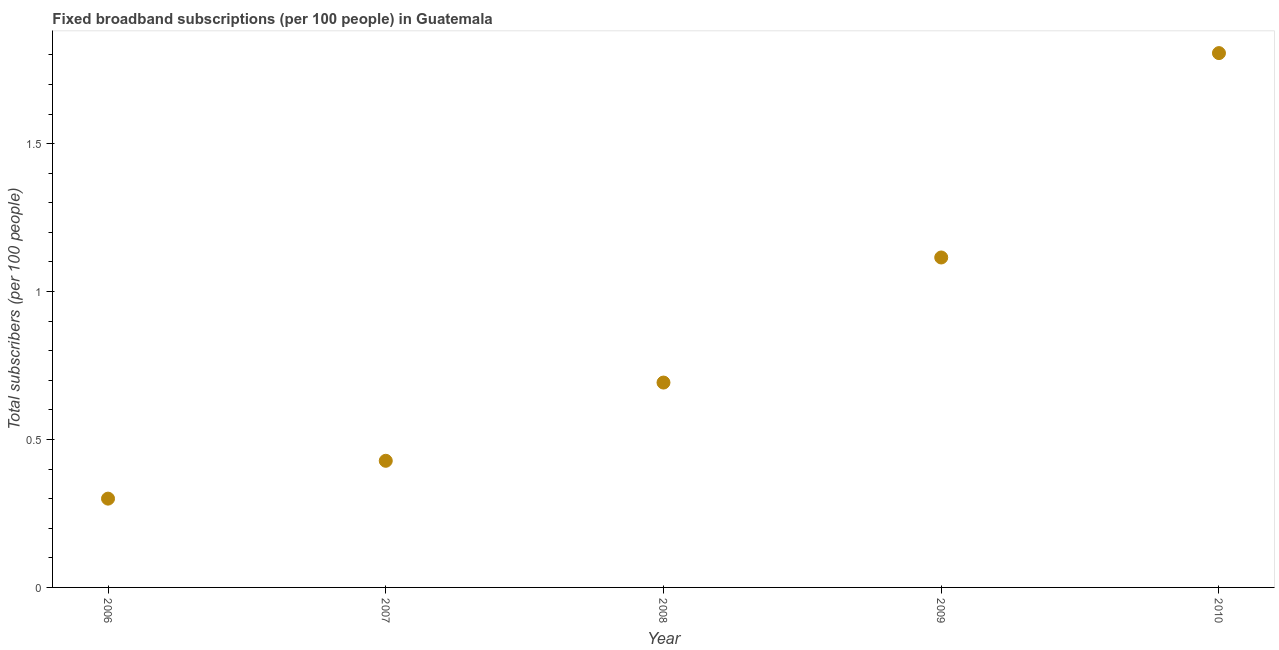What is the total number of fixed broadband subscriptions in 2010?
Offer a very short reply. 1.81. Across all years, what is the maximum total number of fixed broadband subscriptions?
Your answer should be compact. 1.81. Across all years, what is the minimum total number of fixed broadband subscriptions?
Provide a short and direct response. 0.3. In which year was the total number of fixed broadband subscriptions maximum?
Keep it short and to the point. 2010. In which year was the total number of fixed broadband subscriptions minimum?
Ensure brevity in your answer.  2006. What is the sum of the total number of fixed broadband subscriptions?
Your answer should be very brief. 4.34. What is the difference between the total number of fixed broadband subscriptions in 2006 and 2009?
Your answer should be compact. -0.82. What is the average total number of fixed broadband subscriptions per year?
Offer a terse response. 0.87. What is the median total number of fixed broadband subscriptions?
Ensure brevity in your answer.  0.69. In how many years, is the total number of fixed broadband subscriptions greater than 0.4 ?
Provide a short and direct response. 4. What is the ratio of the total number of fixed broadband subscriptions in 2008 to that in 2009?
Your response must be concise. 0.62. Is the difference between the total number of fixed broadband subscriptions in 2008 and 2009 greater than the difference between any two years?
Provide a succinct answer. No. What is the difference between the highest and the second highest total number of fixed broadband subscriptions?
Ensure brevity in your answer.  0.69. Is the sum of the total number of fixed broadband subscriptions in 2006 and 2007 greater than the maximum total number of fixed broadband subscriptions across all years?
Your answer should be compact. No. What is the difference between the highest and the lowest total number of fixed broadband subscriptions?
Offer a terse response. 1.51. Does the graph contain any zero values?
Offer a very short reply. No. What is the title of the graph?
Keep it short and to the point. Fixed broadband subscriptions (per 100 people) in Guatemala. What is the label or title of the X-axis?
Your answer should be very brief. Year. What is the label or title of the Y-axis?
Ensure brevity in your answer.  Total subscribers (per 100 people). What is the Total subscribers (per 100 people) in 2006?
Ensure brevity in your answer.  0.3. What is the Total subscribers (per 100 people) in 2007?
Provide a succinct answer. 0.43. What is the Total subscribers (per 100 people) in 2008?
Offer a terse response. 0.69. What is the Total subscribers (per 100 people) in 2009?
Provide a succinct answer. 1.12. What is the Total subscribers (per 100 people) in 2010?
Your answer should be compact. 1.81. What is the difference between the Total subscribers (per 100 people) in 2006 and 2007?
Provide a short and direct response. -0.13. What is the difference between the Total subscribers (per 100 people) in 2006 and 2008?
Your answer should be very brief. -0.39. What is the difference between the Total subscribers (per 100 people) in 2006 and 2009?
Your answer should be very brief. -0.82. What is the difference between the Total subscribers (per 100 people) in 2006 and 2010?
Provide a succinct answer. -1.51. What is the difference between the Total subscribers (per 100 people) in 2007 and 2008?
Give a very brief answer. -0.26. What is the difference between the Total subscribers (per 100 people) in 2007 and 2009?
Make the answer very short. -0.69. What is the difference between the Total subscribers (per 100 people) in 2007 and 2010?
Offer a very short reply. -1.38. What is the difference between the Total subscribers (per 100 people) in 2008 and 2009?
Offer a very short reply. -0.42. What is the difference between the Total subscribers (per 100 people) in 2008 and 2010?
Give a very brief answer. -1.11. What is the difference between the Total subscribers (per 100 people) in 2009 and 2010?
Make the answer very short. -0.69. What is the ratio of the Total subscribers (per 100 people) in 2006 to that in 2007?
Your answer should be compact. 0.7. What is the ratio of the Total subscribers (per 100 people) in 2006 to that in 2008?
Offer a very short reply. 0.43. What is the ratio of the Total subscribers (per 100 people) in 2006 to that in 2009?
Ensure brevity in your answer.  0.27. What is the ratio of the Total subscribers (per 100 people) in 2006 to that in 2010?
Give a very brief answer. 0.17. What is the ratio of the Total subscribers (per 100 people) in 2007 to that in 2008?
Provide a succinct answer. 0.62. What is the ratio of the Total subscribers (per 100 people) in 2007 to that in 2009?
Give a very brief answer. 0.38. What is the ratio of the Total subscribers (per 100 people) in 2007 to that in 2010?
Offer a very short reply. 0.24. What is the ratio of the Total subscribers (per 100 people) in 2008 to that in 2009?
Offer a very short reply. 0.62. What is the ratio of the Total subscribers (per 100 people) in 2008 to that in 2010?
Your response must be concise. 0.38. What is the ratio of the Total subscribers (per 100 people) in 2009 to that in 2010?
Make the answer very short. 0.62. 